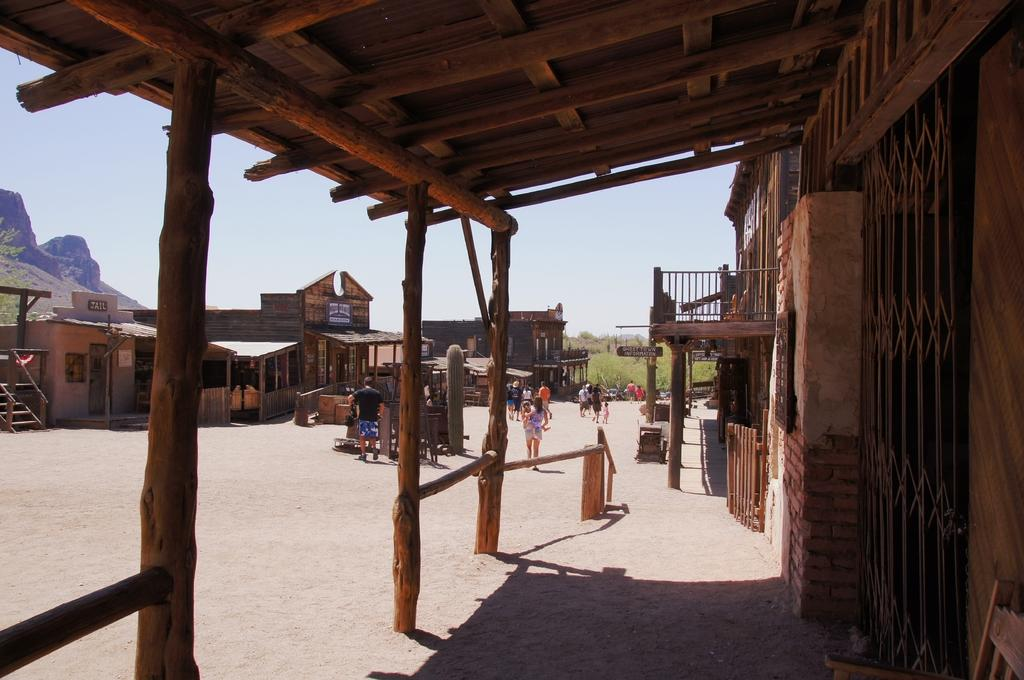What type of structure can be seen on the right side of the image? There is a wooden roof on the right side of the image. What is happening in the middle of the image? There are people walking in the middle of the image. Reasoning: Let'g: Let's think step by step in order to produce the conversation. We start by identifying the main subjects and objects in the image based on the provided facts. We then formulate questions that focus on the location and characteristics of these subjects and objects, ensuring that each question can be answered definitively with the information given. We avoid yes/no questions and ensure that the language is simple and clear. Absurd Question/Answer: What invention is being used by the snails in the image? There are no snails present in the image, so no invention can be attributed to them. How many teeth can be seen on the wooden roof in the image? There are no teeth present on the wooden roof in the image, as it is a structure made of wood. 